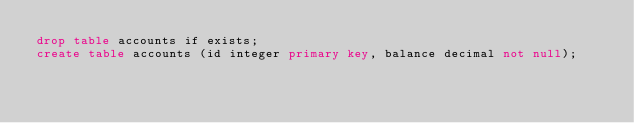Convert code to text. <code><loc_0><loc_0><loc_500><loc_500><_SQL_>drop table accounts if exists;
create table accounts (id integer primary key, balance decimal not null);</code> 